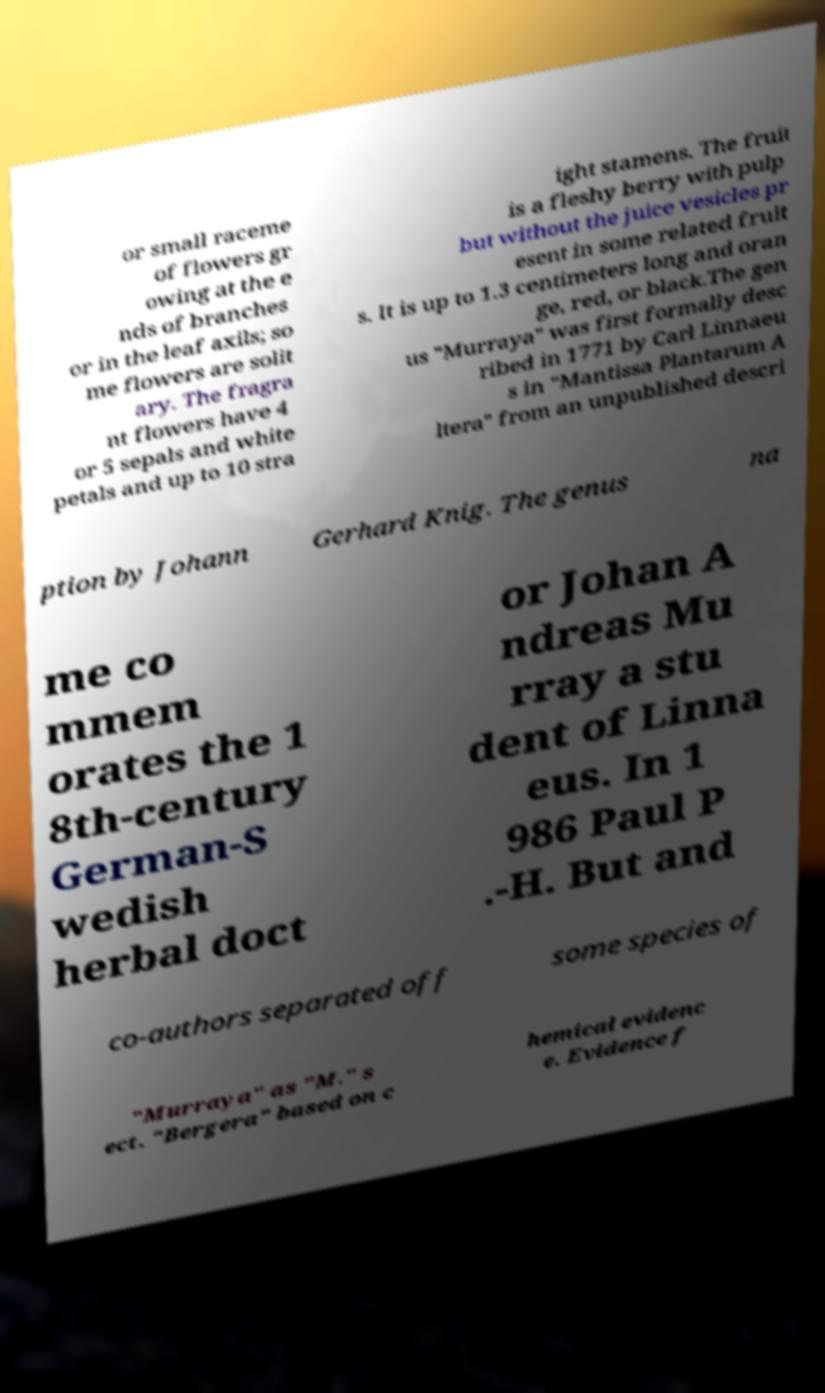Please read and relay the text visible in this image. What does it say? or small raceme of flowers gr owing at the e nds of branches or in the leaf axils; so me flowers are solit ary. The fragra nt flowers have 4 or 5 sepals and white petals and up to 10 stra ight stamens. The fruit is a fleshy berry with pulp but without the juice vesicles pr esent in some related fruit s. It is up to 1.3 centimeters long and oran ge, red, or black.The gen us "Murraya" was first formally desc ribed in 1771 by Carl Linnaeu s in "Mantissa Plantarum A ltera" from an unpublished descri ption by Johann Gerhard Knig. The genus na me co mmem orates the 1 8th-century German-S wedish herbal doct or Johan A ndreas Mu rray a stu dent of Linna eus. In 1 986 Paul P .-H. But and co-authors separated off some species of "Murraya" as "M." s ect. "Bergera" based on c hemical evidenc e. Evidence f 